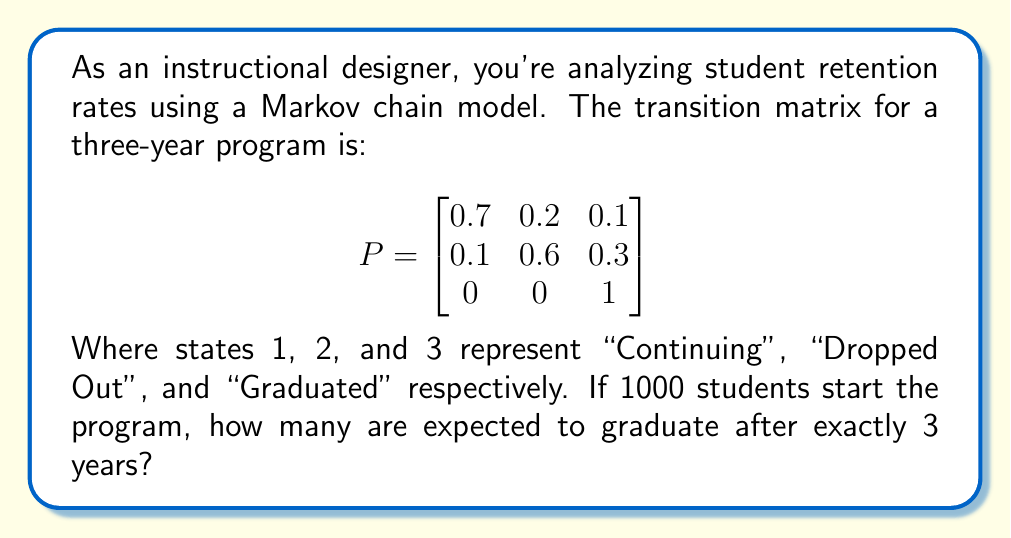Solve this math problem. Let's approach this step-by-step:

1) We need to calculate the probability of a student being in state 3 (Graduated) after exactly 3 years.

2) This can be done by raising the transition matrix to the power of 3 and looking at the element in the first row, third column:

   $$P^3 = \begin{bmatrix}
   0.7 & 0.2 & 0.1 \\
   0.1 & 0.6 & 0.3 \\
   0 & 0 & 1
   \end{bmatrix}^3$$

3) Calculating $P^3$:

   $$P^3 = \begin{bmatrix}
   0.406 & 0.328 & 0.266 \\
   0.147 & 0.384 & 0.469 \\
   0 & 0 & 1
   \end{bmatrix}$$

4) The probability of graduating after exactly 3 years, starting from state 1, is 0.266.

5) With 1000 students starting, the expected number of graduates after exactly 3 years is:

   $1000 \times 0.266 = 266$
Answer: 266 students 